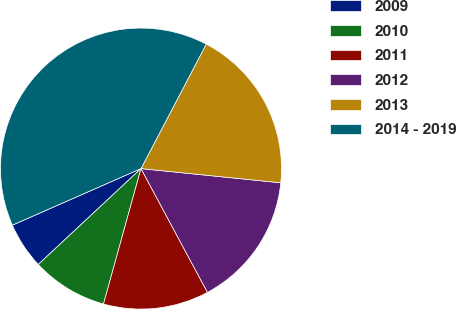<chart> <loc_0><loc_0><loc_500><loc_500><pie_chart><fcel>2009<fcel>2010<fcel>2011<fcel>2012<fcel>2013<fcel>2014 - 2019<nl><fcel>5.36%<fcel>8.75%<fcel>12.14%<fcel>15.54%<fcel>18.93%<fcel>39.28%<nl></chart> 